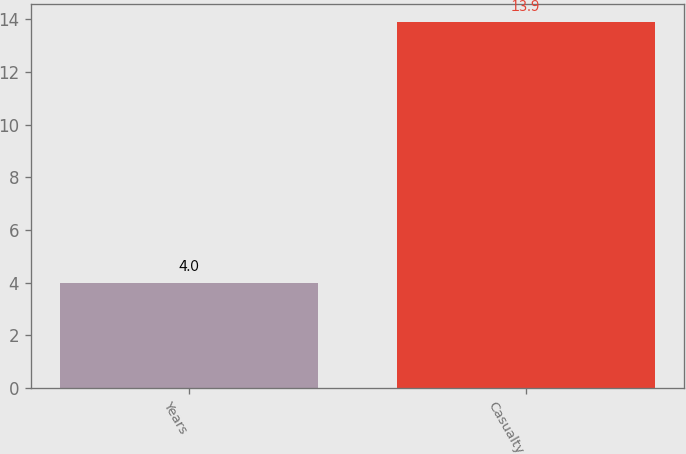Convert chart to OTSL. <chart><loc_0><loc_0><loc_500><loc_500><bar_chart><fcel>Years<fcel>Casualty<nl><fcel>4<fcel>13.9<nl></chart> 